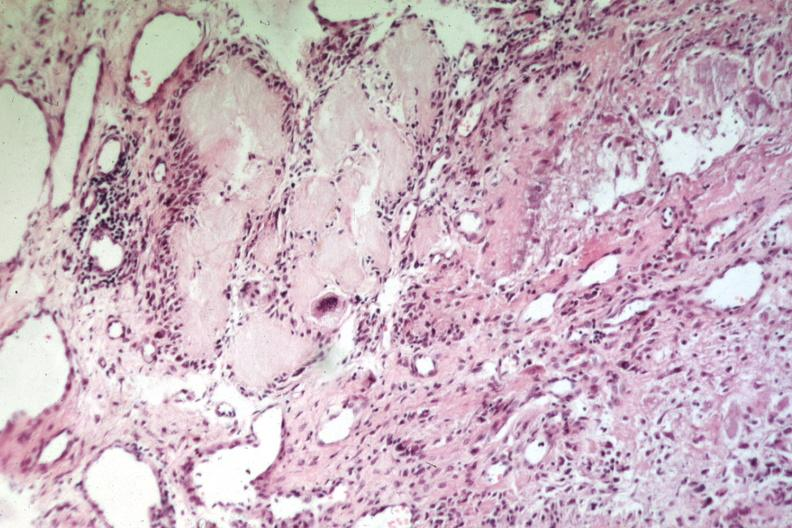does this image show uric acid deposits with giant cells easily recognizable as gout or uric acid tophus?
Answer the question using a single word or phrase. Yes 